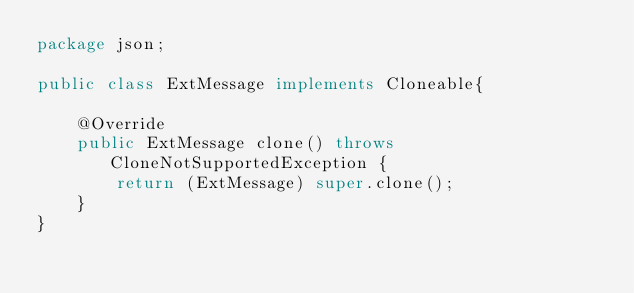<code> <loc_0><loc_0><loc_500><loc_500><_Java_>package json;

public class ExtMessage implements Cloneable{

    @Override
    public ExtMessage clone() throws CloneNotSupportedException {
        return (ExtMessage) super.clone();
    }
}
</code> 